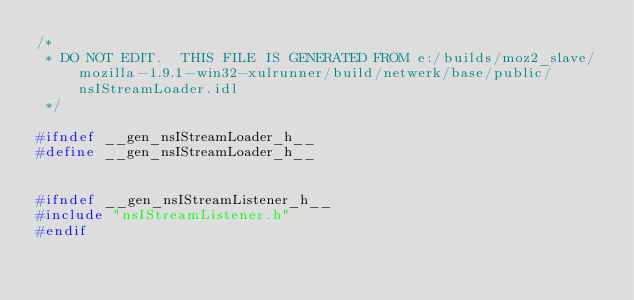Convert code to text. <code><loc_0><loc_0><loc_500><loc_500><_C_>/*
 * DO NOT EDIT.  THIS FILE IS GENERATED FROM e:/builds/moz2_slave/mozilla-1.9.1-win32-xulrunner/build/netwerk/base/public/nsIStreamLoader.idl
 */

#ifndef __gen_nsIStreamLoader_h__
#define __gen_nsIStreamLoader_h__


#ifndef __gen_nsIStreamListener_h__
#include "nsIStreamListener.h"
#endif</code> 